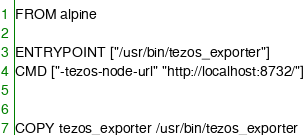<code> <loc_0><loc_0><loc_500><loc_500><_Dockerfile_>FROM alpine

ENTRYPOINT ["/usr/bin/tezos_exporter"]
CMD ["-tezos-node-url" "http://localhost:8732/"]


COPY tezos_exporter /usr/bin/tezos_exporter
</code> 